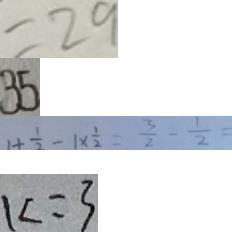<formula> <loc_0><loc_0><loc_500><loc_500>= 2 9 
 3 5 
 1 + \frac { 1 } { 2 } - 1 \times \frac { 1 } { 2 } = \frac { 3 } { 2 } - \frac { 1 } { 2 } = 
 k = 3</formula> 